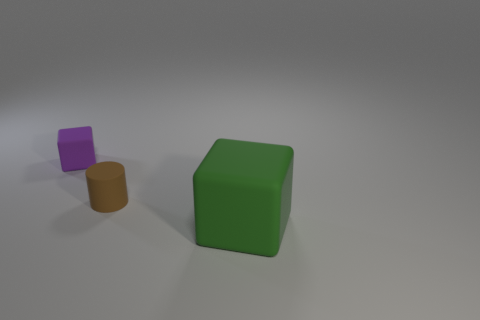Is there a purple metallic object that has the same size as the purple matte cube?
Offer a terse response. No. How many objects are either small red shiny cubes or cylinders?
Your answer should be very brief. 1. There is a brown object in front of the tiny purple object; does it have the same size as the block that is in front of the small purple cube?
Give a very brief answer. No. Are there any large matte objects that have the same shape as the small brown thing?
Ensure brevity in your answer.  No. Are there fewer matte cylinders that are left of the purple rubber cube than small purple matte cubes?
Your response must be concise. Yes. Is the big rubber object the same shape as the small purple object?
Give a very brief answer. Yes. There is a matte cube on the right side of the purple object; what is its size?
Keep it short and to the point. Large. What is the size of the brown thing that is made of the same material as the green thing?
Give a very brief answer. Small. Are there fewer tiny rubber blocks than large blue rubber spheres?
Your response must be concise. No. Is the number of purple cubes greater than the number of rubber things?
Provide a short and direct response. No. 